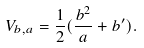<formula> <loc_0><loc_0><loc_500><loc_500>V _ { b , a } = \frac { 1 } { 2 } ( \frac { b ^ { 2 } } a + b ^ { \prime } ) .</formula> 